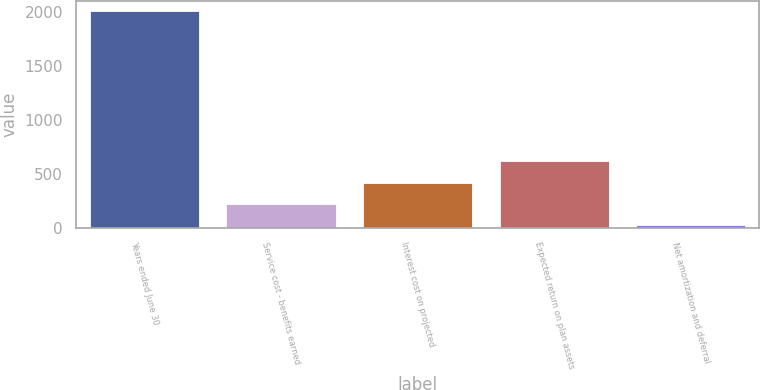<chart> <loc_0><loc_0><loc_500><loc_500><bar_chart><fcel>Years ended June 30<fcel>Service cost - benefits earned<fcel>Interest cost on projected<fcel>Expected return on plan assets<fcel>Net amortization and deferral<nl><fcel>2006<fcel>217.97<fcel>416.64<fcel>615.31<fcel>19.3<nl></chart> 